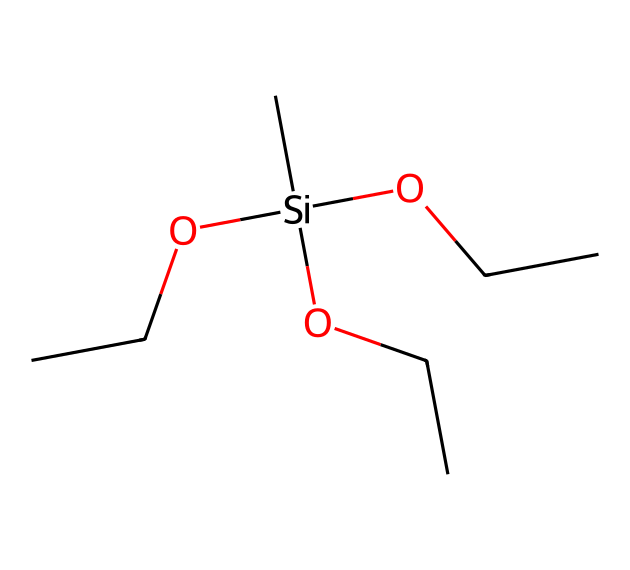What is the total number of carbon atoms in the structure? By examining the SMILES representation, I can count the carbon atoms present. The structure C[Si](OCC)(OCC)OCC contains three OCC groups, and each OCC has two carbon atoms plus one additional carbon in the main chain, totaling seven carbon atoms.
Answer: seven How many silicon atoms are in this chemical? In the given SMILES, there is only one silicon atom denoted by "Si". Thus, the total count of silicon atoms is one.
Answer: one What type of chemical compound is represented here? The main feature of the structure is the presence of silicon bonded to organic groups and hydroxyl groups, which indicates that this chemical is a silane.
Answer: silane What are the functional groups present in this molecule? The molecule contains silanol (due to Si-OH) and ether functional groups (from the OCC moieties), identifying it as having both functionalities.
Answer: silanol and ether How many ethyl (OCC) groups are attached to the silicon atom? By analyzing the connection points from the silicon atom, it is clear that there are three OCC groups attached to it.
Answer: three What is the primary application of this silane compound in construction? The compound is designed as a water repellent, enhancing the durability and sustainability of construction materials by preventing the ingress of water.
Answer: water repellent What kind of bonding is observed between silicon and the surrounding groups? The silicon atom forms covalent bonds with the carbon-containing ethyl groups and hydroxyl, showcasing typical silane bonding characteristics.
Answer: covalent bonding 